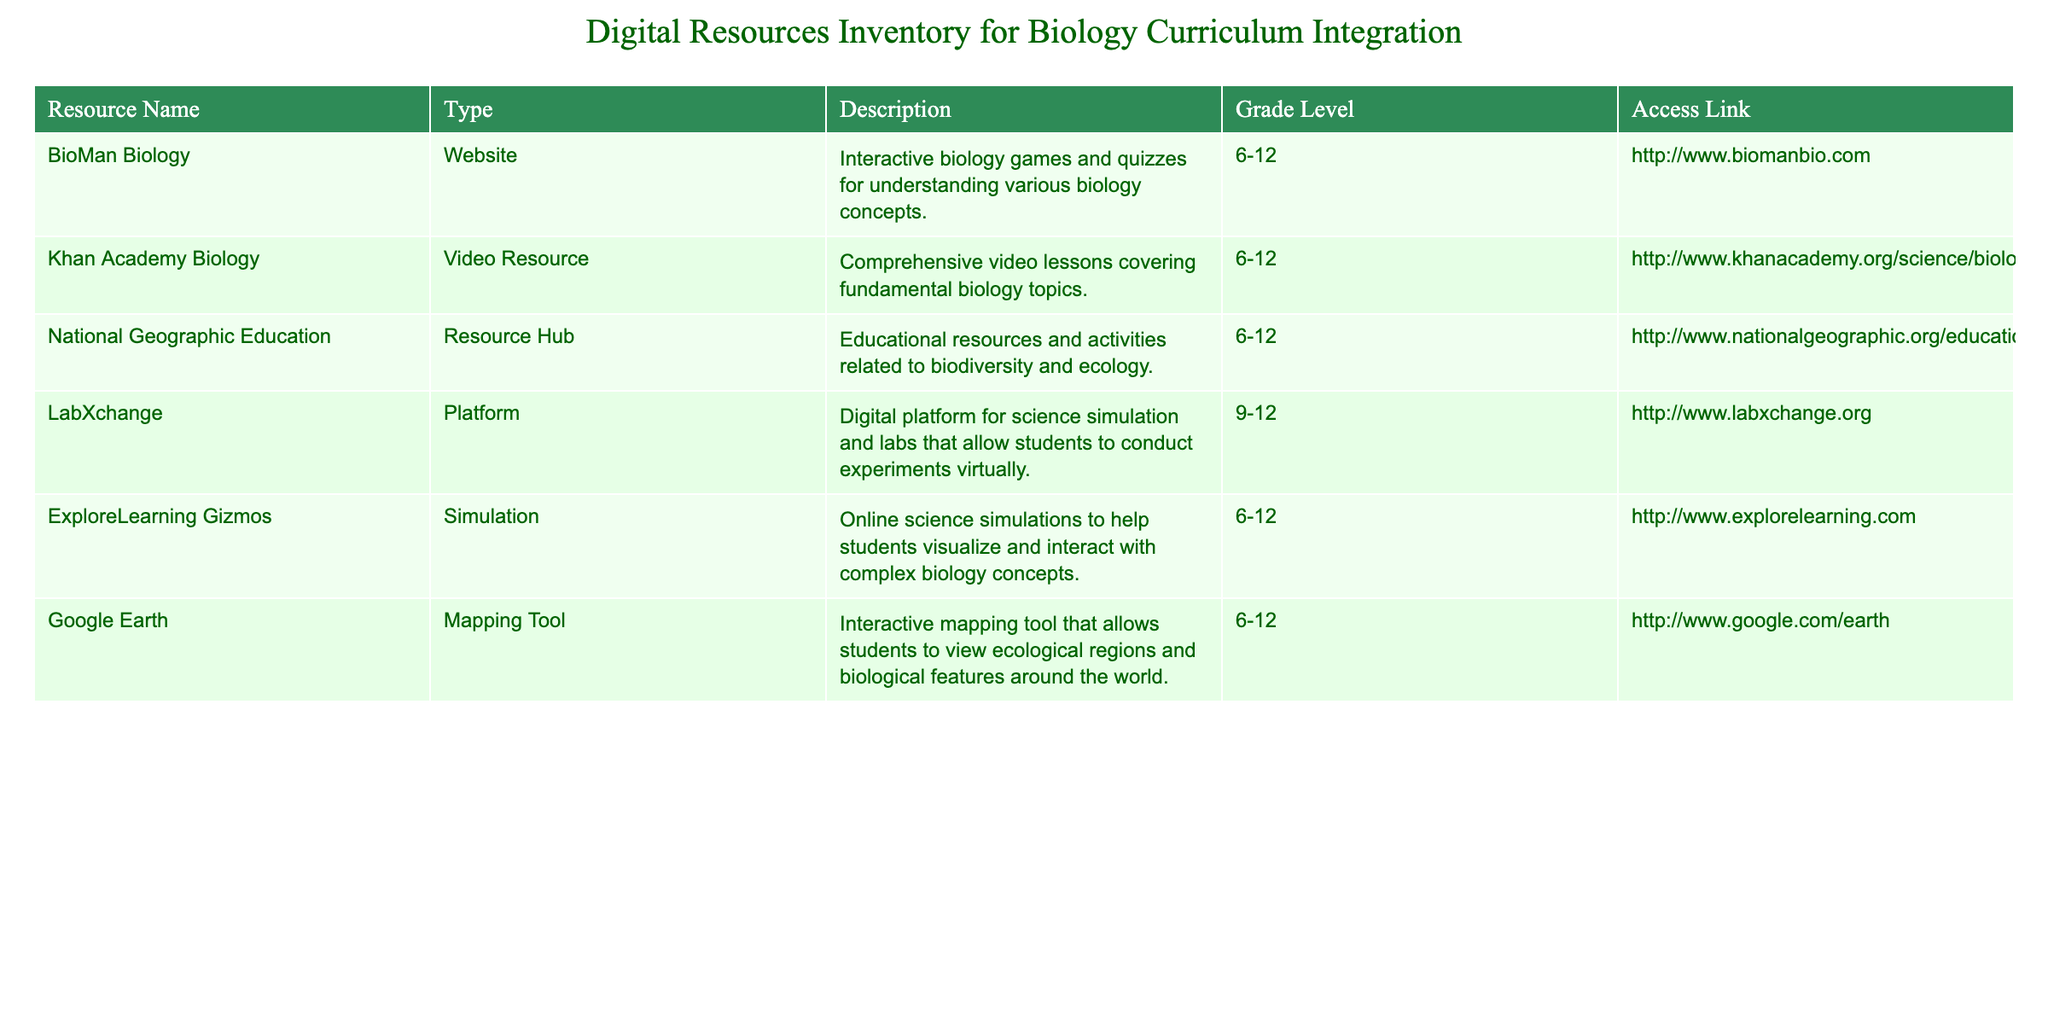What type of resource is "Khan Academy Biology"? The table lists the resource type of "Khan Academy Biology" as "Video Resource". Therefore, a direct reference to the table confirms this information.
Answer: Video Resource Which resources are suitable for grade levels 9-12? By scanning the table, we can identify that "LabXchange" is marked for grades 9-12. The only other resources for grades 6-12 do not meet the criteria. Thus, the only resource is "LabXchange".
Answer: LabXchange Is "ExploreLearning Gizmos" accessible to students in grades 6-12? Yes, according to the table, "ExploreLearning Gizmos" lists the grade level as 6-12, indicating that it is accessible for those students.
Answer: Yes How many resources are described as platforms in the table? There is one resource described as a platform, which is "LabXchange". All other resources are categorized differently (e.g., website, simulation). Therefore, the count is one.
Answer: 1 What resources are focused on interactive learning? "BioMan Biology", "ExploreLearning Gizmos", and "LabXchange" all emphasize interactive and participatory experiences for students, catering to engaging learning. These resources can be identified in the description column.
Answer: BioMan Biology, ExploreLearning Gizmos, LabXchange What is the difference between the number of video resources and simulation resources? The table includes one video resource ("Khan Academy Biology") and one simulation resource ("ExploreLearning Gizmos"). Subtracting the quantities of each gives 1 - 1 = 0, indicating no difference.
Answer: 0 Can students access "National Geographic Education" for grades 4-5? No, the table specifies that "National Geographic Education" is suitable for grades 6-12, indicating it is not accessible for students in grades 4-5.
Answer: No Which resource has the longest description? By comparing the lengths of the descriptions in the table, "LabXchange" has the longest description detailing its platform for virtual experiments. This involves reading the descriptive field of each entry to compare length.
Answer: LabXchange Which mapping tool can students use to learn about ecological regions? The table shows that "Google Earth" is categorized as a mapping tool and explains its function related to viewing ecological regions. A direct reading from the table confirms this.
Answer: Google Earth 